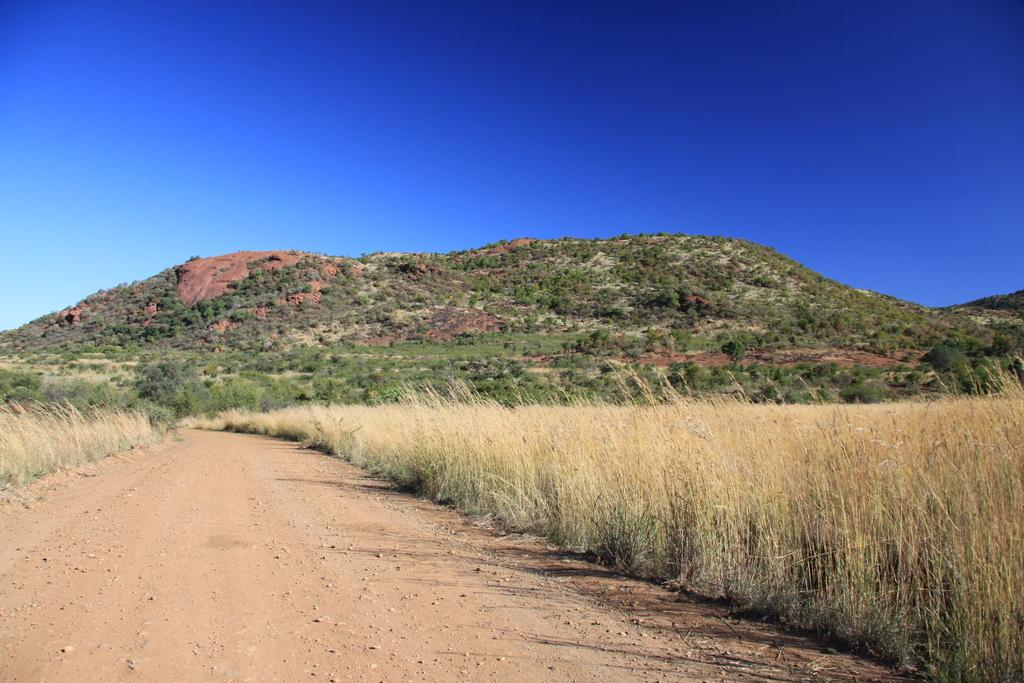What type of vegetation is present in the image? There is dried grass in the image. What geographical feature can be seen in the image? The image appears to depict a hill. What type of plants are on the hill? There are trees on the hill. What can be used for walking or traveling on the hill? There is a pathway visible in the image. What is visible above the hill in the image? The sky is visible in the image. What rule is being enforced by the trees on the hill in the image? There is no rule being enforced by the trees in the image; they are simply plants growing on the hill. 